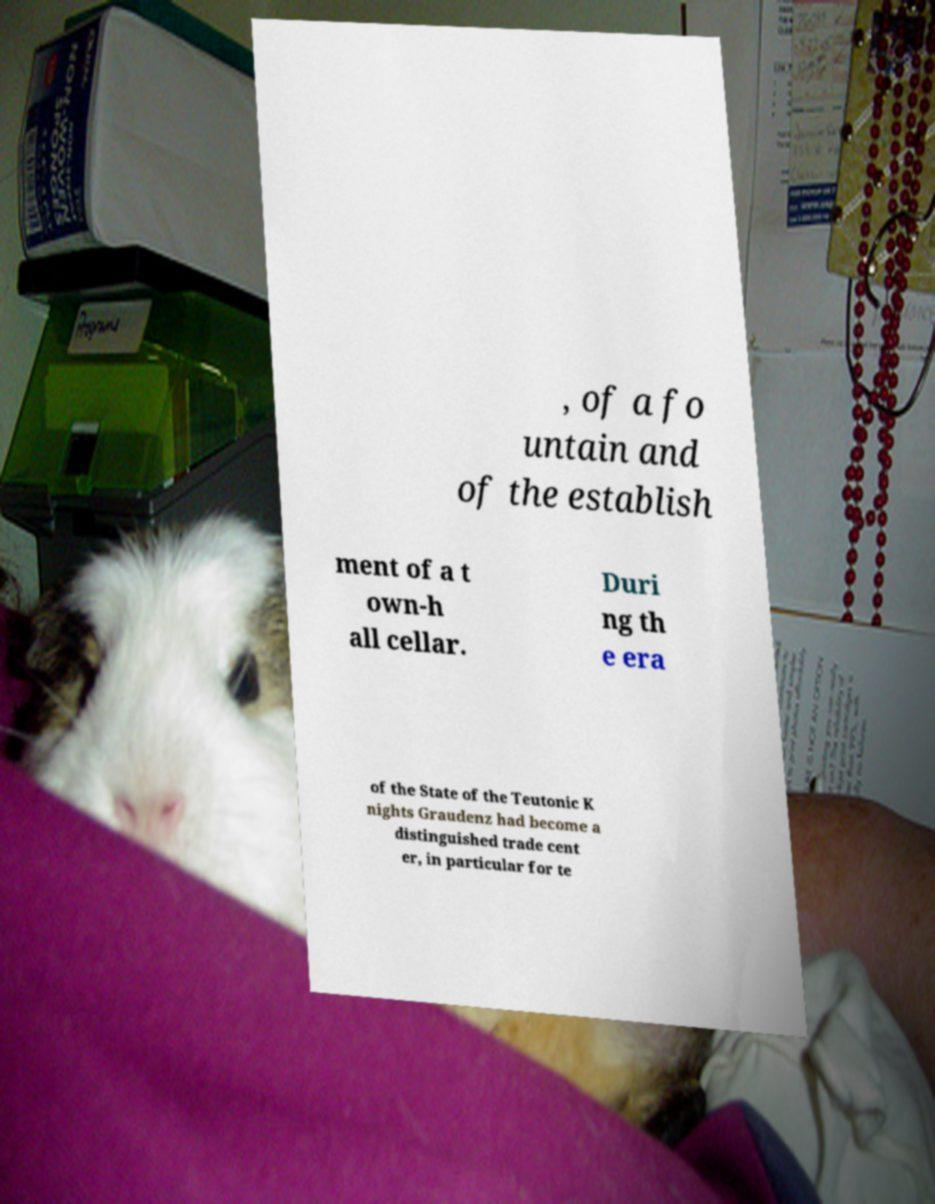I need the written content from this picture converted into text. Can you do that? , of a fo untain and of the establish ment of a t own-h all cellar. Duri ng th e era of the State of the Teutonic K nights Graudenz had become a distinguished trade cent er, in particular for te 